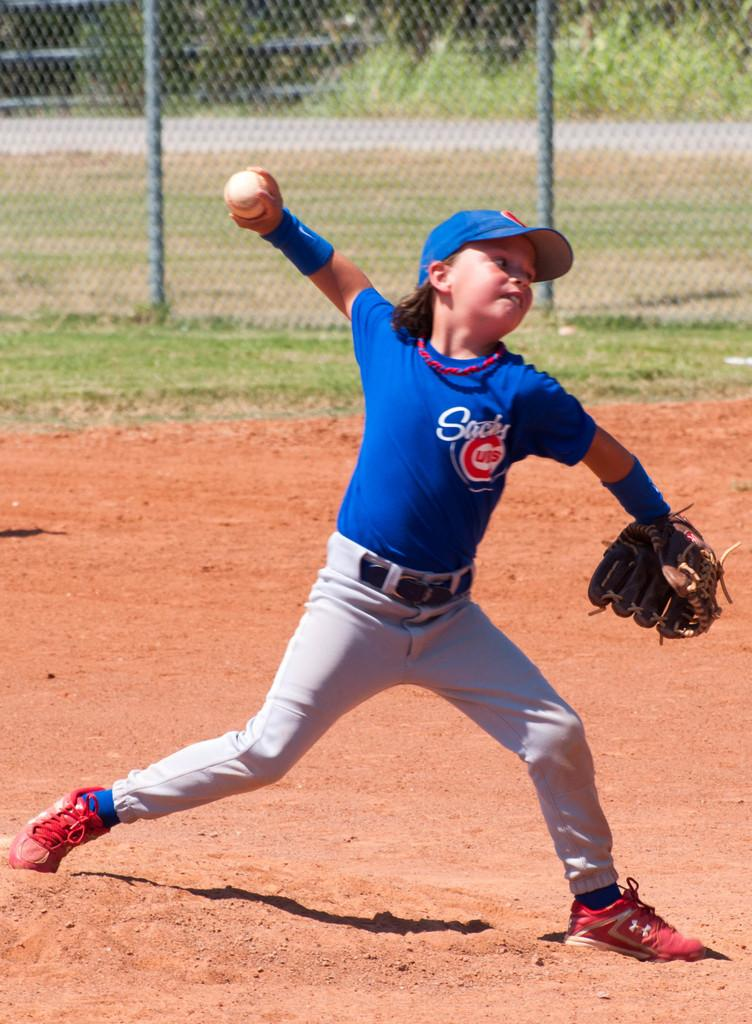<image>
Relay a brief, clear account of the picture shown. The little leaguer has a Cubs logo on their chest. 